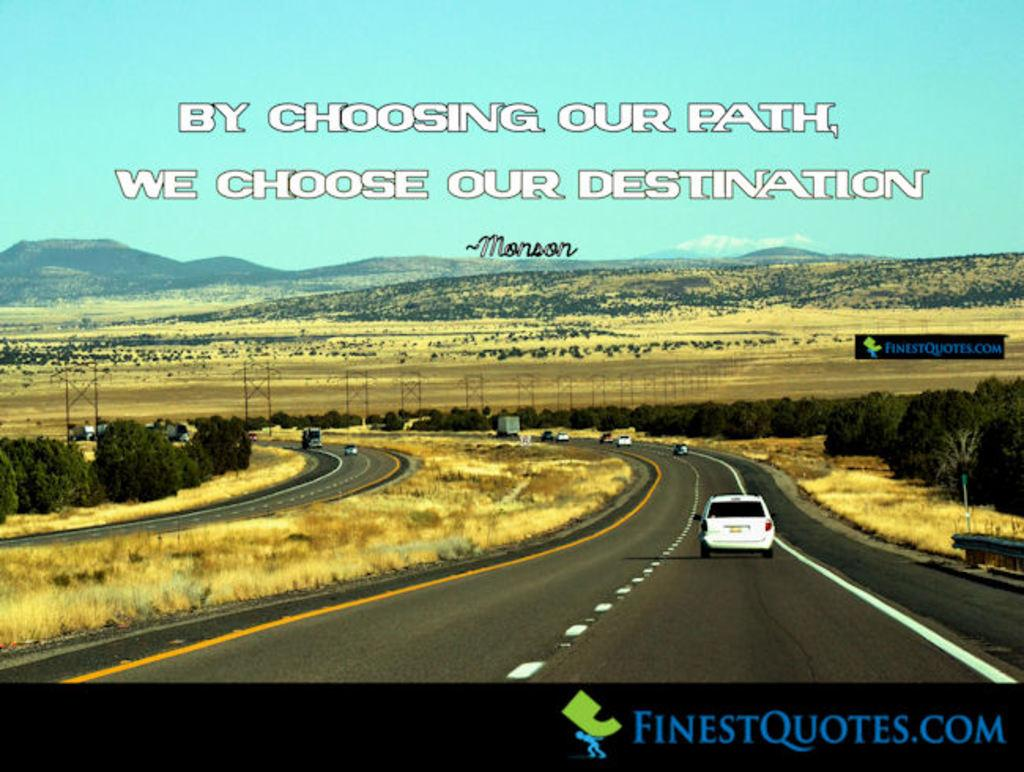What can be seen on the roads in the image? There are vehicles on the roads in the image. What type of natural environment is visible in the background of the image? There are trees, grass, hills, and the sky visible in the background of the image. What else can be seen in the background of the image? There are other objects in the background of the image. Is there any text or writing present in the image? Yes, there is something written on the image. Can you tell me how many times the cook slipped while preparing the meal in the image? There is no cook or meal preparation present in the image; it features vehicles on roads with a natural background. What type of error can be seen in the image? There is no error present in the image; it is a clear and accurate representation of the scene. 